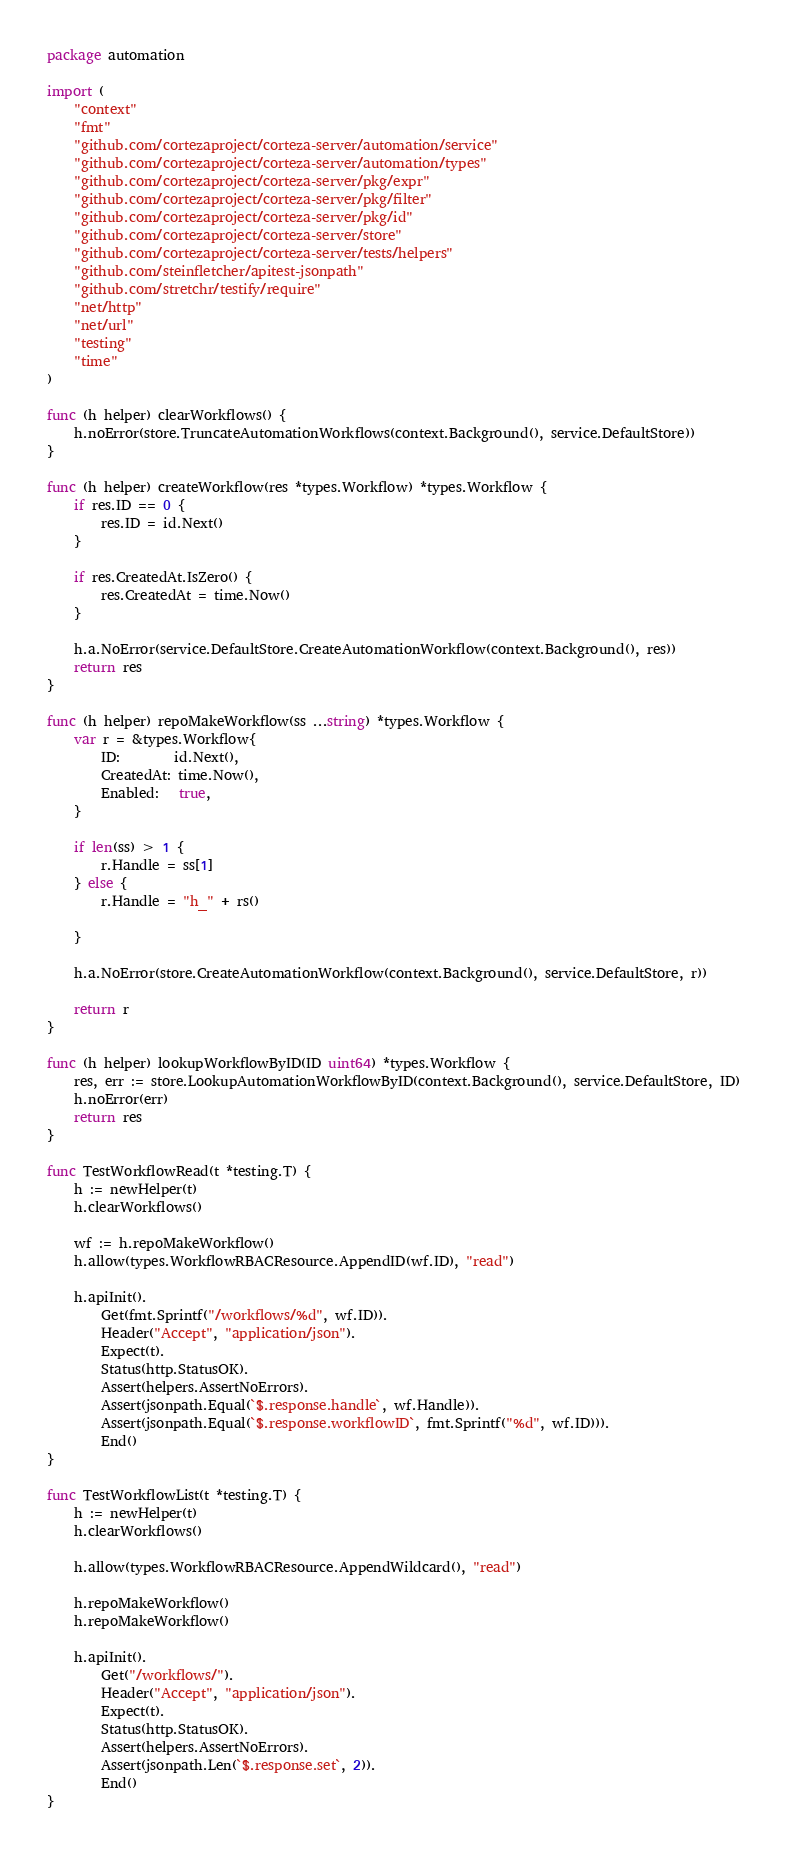Convert code to text. <code><loc_0><loc_0><loc_500><loc_500><_Go_>package automation

import (
	"context"
	"fmt"
	"github.com/cortezaproject/corteza-server/automation/service"
	"github.com/cortezaproject/corteza-server/automation/types"
	"github.com/cortezaproject/corteza-server/pkg/expr"
	"github.com/cortezaproject/corteza-server/pkg/filter"
	"github.com/cortezaproject/corteza-server/pkg/id"
	"github.com/cortezaproject/corteza-server/store"
	"github.com/cortezaproject/corteza-server/tests/helpers"
	"github.com/steinfletcher/apitest-jsonpath"
	"github.com/stretchr/testify/require"
	"net/http"
	"net/url"
	"testing"
	"time"
)

func (h helper) clearWorkflows() {
	h.noError(store.TruncateAutomationWorkflows(context.Background(), service.DefaultStore))
}

func (h helper) createWorkflow(res *types.Workflow) *types.Workflow {
	if res.ID == 0 {
		res.ID = id.Next()
	}

	if res.CreatedAt.IsZero() {
		res.CreatedAt = time.Now()
	}

	h.a.NoError(service.DefaultStore.CreateAutomationWorkflow(context.Background(), res))
	return res
}

func (h helper) repoMakeWorkflow(ss ...string) *types.Workflow {
	var r = &types.Workflow{
		ID:        id.Next(),
		CreatedAt: time.Now(),
		Enabled:   true,
	}

	if len(ss) > 1 {
		r.Handle = ss[1]
	} else {
		r.Handle = "h_" + rs()

	}

	h.a.NoError(store.CreateAutomationWorkflow(context.Background(), service.DefaultStore, r))

	return r
}

func (h helper) lookupWorkflowByID(ID uint64) *types.Workflow {
	res, err := store.LookupAutomationWorkflowByID(context.Background(), service.DefaultStore, ID)
	h.noError(err)
	return res
}

func TestWorkflowRead(t *testing.T) {
	h := newHelper(t)
	h.clearWorkflows()

	wf := h.repoMakeWorkflow()
	h.allow(types.WorkflowRBACResource.AppendID(wf.ID), "read")

	h.apiInit().
		Get(fmt.Sprintf("/workflows/%d", wf.ID)).
		Header("Accept", "application/json").
		Expect(t).
		Status(http.StatusOK).
		Assert(helpers.AssertNoErrors).
		Assert(jsonpath.Equal(`$.response.handle`, wf.Handle)).
		Assert(jsonpath.Equal(`$.response.workflowID`, fmt.Sprintf("%d", wf.ID))).
		End()
}

func TestWorkflowList(t *testing.T) {
	h := newHelper(t)
	h.clearWorkflows()

	h.allow(types.WorkflowRBACResource.AppendWildcard(), "read")

	h.repoMakeWorkflow()
	h.repoMakeWorkflow()

	h.apiInit().
		Get("/workflows/").
		Header("Accept", "application/json").
		Expect(t).
		Status(http.StatusOK).
		Assert(helpers.AssertNoErrors).
		Assert(jsonpath.Len(`$.response.set`, 2)).
		End()
}
</code> 